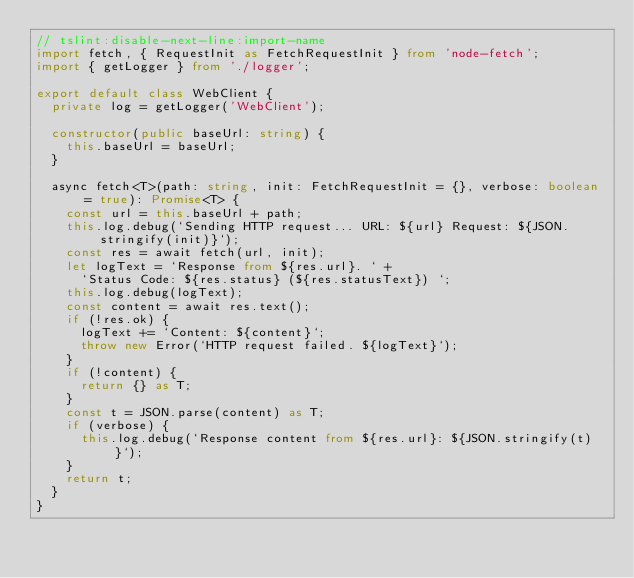<code> <loc_0><loc_0><loc_500><loc_500><_TypeScript_>// tslint:disable-next-line:import-name
import fetch, { RequestInit as FetchRequestInit } from 'node-fetch';
import { getLogger } from './logger';

export default class WebClient {
  private log = getLogger('WebClient');

  constructor(public baseUrl: string) {
    this.baseUrl = baseUrl;
  }

  async fetch<T>(path: string, init: FetchRequestInit = {}, verbose: boolean = true): Promise<T> {
    const url = this.baseUrl + path;
    this.log.debug(`Sending HTTP request... URL: ${url} Request: ${JSON.stringify(init)}`);
    const res = await fetch(url, init);
    let logText = `Response from ${res.url}. ` +
      `Status Code: ${res.status} (${res.statusText}) `;
    this.log.debug(logText);    
    const content = await res.text();
    if (!res.ok) {      
      logText += `Content: ${content}`;
      throw new Error(`HTTP request failed. ${logText}`);
    }    
    if (!content) {
      return {} as T;
    }
    const t = JSON.parse(content) as T;
    if (verbose) {
      this.log.debug(`Response content from ${res.url}: ${JSON.stringify(t)}`);
    }
    return t;
  }
}</code> 